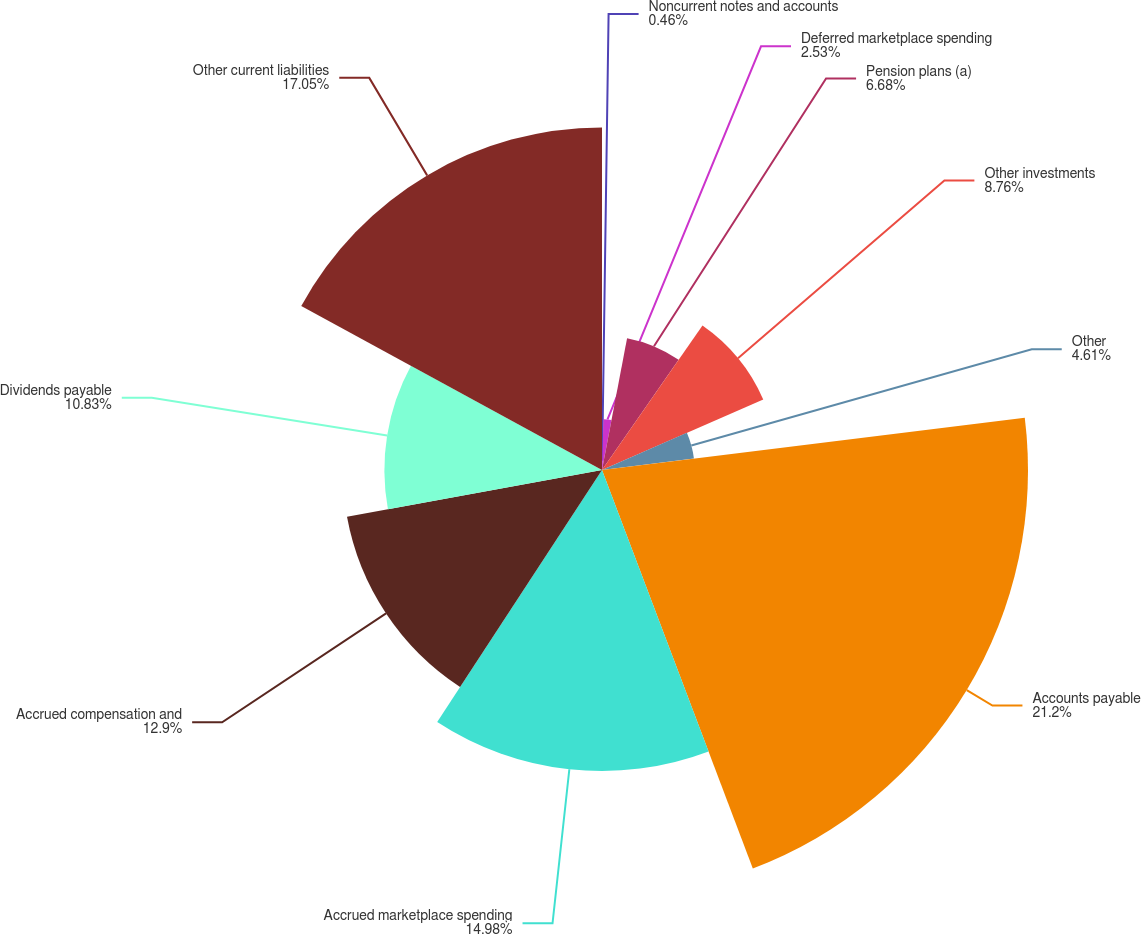<chart> <loc_0><loc_0><loc_500><loc_500><pie_chart><fcel>Noncurrent notes and accounts<fcel>Deferred marketplace spending<fcel>Pension plans (a)<fcel>Other investments<fcel>Other<fcel>Accounts payable<fcel>Accrued marketplace spending<fcel>Accrued compensation and<fcel>Dividends payable<fcel>Other current liabilities<nl><fcel>0.46%<fcel>2.53%<fcel>6.68%<fcel>8.76%<fcel>4.61%<fcel>21.2%<fcel>14.98%<fcel>12.9%<fcel>10.83%<fcel>17.05%<nl></chart> 